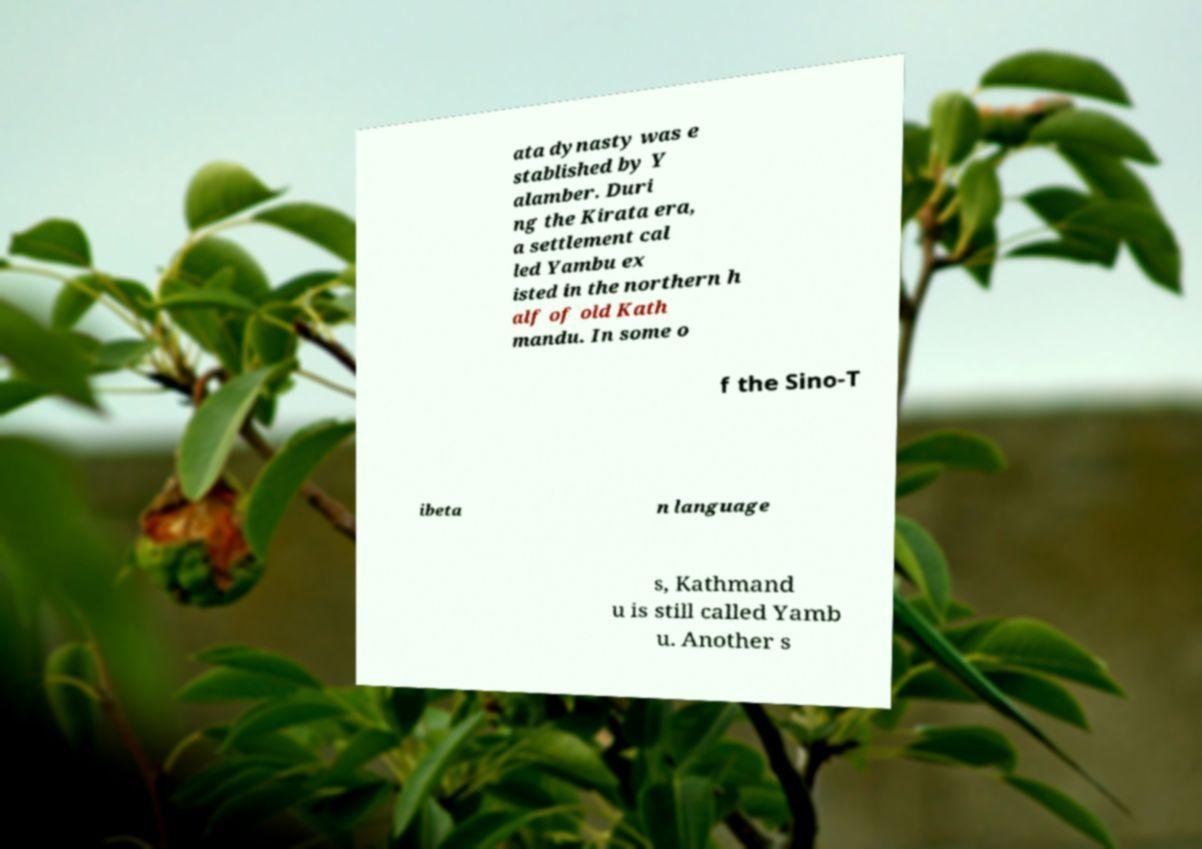For documentation purposes, I need the text within this image transcribed. Could you provide that? ata dynasty was e stablished by Y alamber. Duri ng the Kirata era, a settlement cal led Yambu ex isted in the northern h alf of old Kath mandu. In some o f the Sino-T ibeta n language s, Kathmand u is still called Yamb u. Another s 